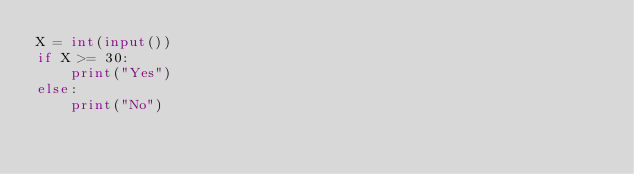Convert code to text. <code><loc_0><loc_0><loc_500><loc_500><_Python_>X = int(input())
if X >= 30:
    print("Yes")
else:
    print("No")
</code> 